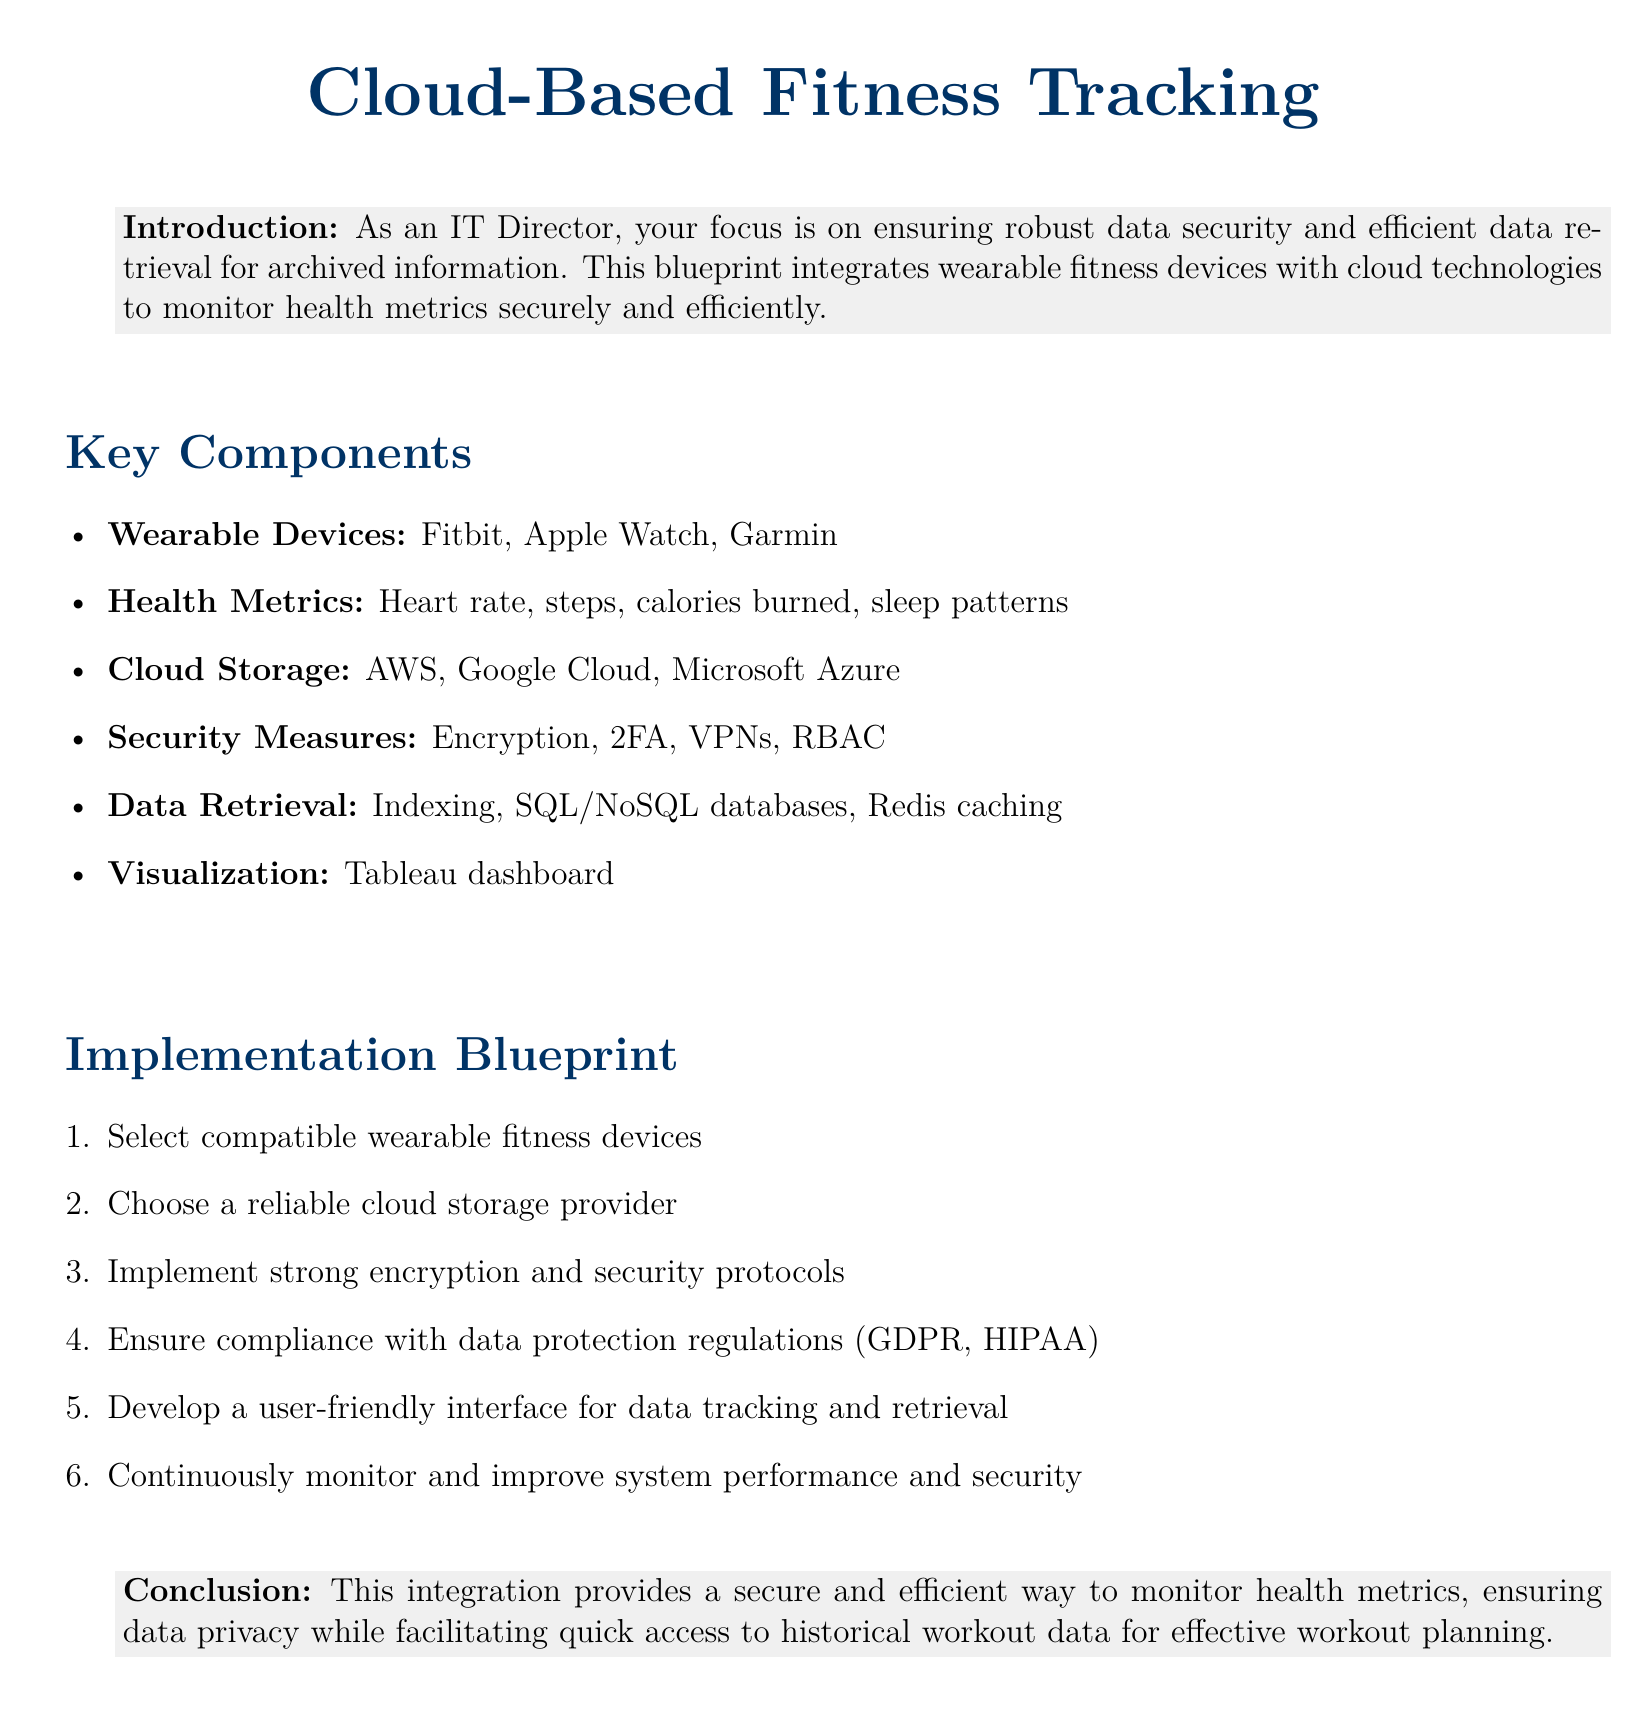What is the primary focus of the blueprint? The blueprint focuses on integrating wearable fitness devices with cloud technologies to monitor health metrics securely and efficiently.
Answer: Data security and efficient retrieval Which wearable devices are mentioned? The document lists specific wearable devices that are recommended for integration, including Fitbit, Apple Watch, and Garmin.
Answer: Fitbit, Apple Watch, Garmin What is one health metric tracked? The document highlights several health metrics, one of which includes heart rate.
Answer: Heart rate What cloud storage providers are suggested? The document identifies reliable cloud storage providers necessary for the implementation, specifically AWS, Google Cloud, and Microsoft Azure.
Answer: AWS, Google Cloud, Microsoft Azure What security measure is listed? Among various security measures, encryption is noted as a key strategy to have in place for data protection.
Answer: Encryption What is the first step in the implementation blueprint? The document outlines a sequence of actions to take, starting with selecting compatible wearable fitness devices.
Answer: Select compatible wearable fitness devices Which dashboard tool is mentioned for visualization? To effectively visualize health metrics, the document suggests using Tableau as the dashboard tool.
Answer: Tableau What regulations should be complied with? Compliance with data protection regulations is emphasized, specifically citing GDPR and HIPAA as critical standards to meet.
Answer: GDPR, HIPAA What is the purpose of indexing in the context of the document? Indexing is highlighted as a technique to enhance data retrieval processes, making historical workout data easier to access.
Answer: Efficient data retrieval 